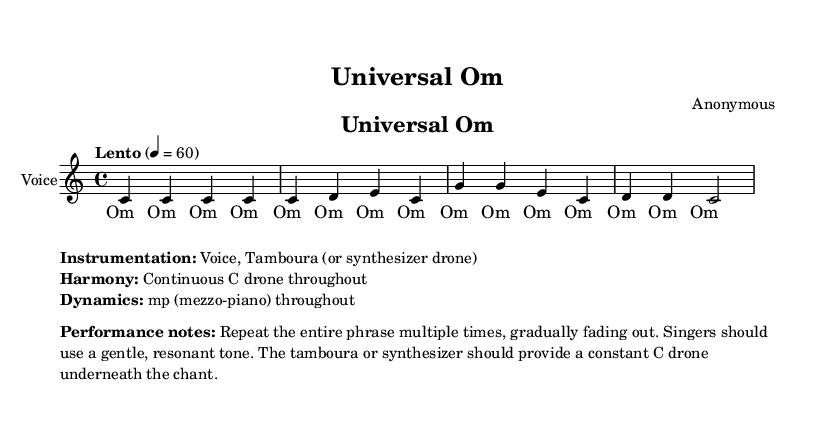What is the key signature of this music? The key signature is C major, which has no sharps or flats.
Answer: C major What is the time signature of this piece? The time signature indicated in the music is 4/4, which means there are four beats per measure.
Answer: 4/4 What is the tempo marking for this piece? The tempo marking is "Lento," which suggests a slow pace. The metronome marking is 60 beats per minute.
Answer: Lento How many measures are in the melody? By counting the musical bars in the melody section, there are a total of four measures.
Answer: 4 What voice type is indicated for the performance? The score indicates that the performance is for "Voice," which suggests a vocal rendition of the chant.
Answer: Voice What is the primary instruction regarding dynamics? The dynamics throughout the piece are indicated as "mp," meaning mezzo-piano, which refers to a moderately soft volume.
Answer: mp What should the performers do according to the performance notes? The performance notes suggest that the entire phrase should be repeated multiple times and should gradually fade out, emphasizing a gentle delivery.
Answer: Repeat multiple times 